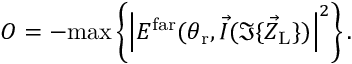<formula> <loc_0><loc_0><loc_500><loc_500>O = - \max \left \{ \left | E ^ { f a r } ( \theta _ { r } , \vec { I } ( \Im \{ \vec { Z } _ { L } \} ) \right | ^ { 2 } \right \} .</formula> 